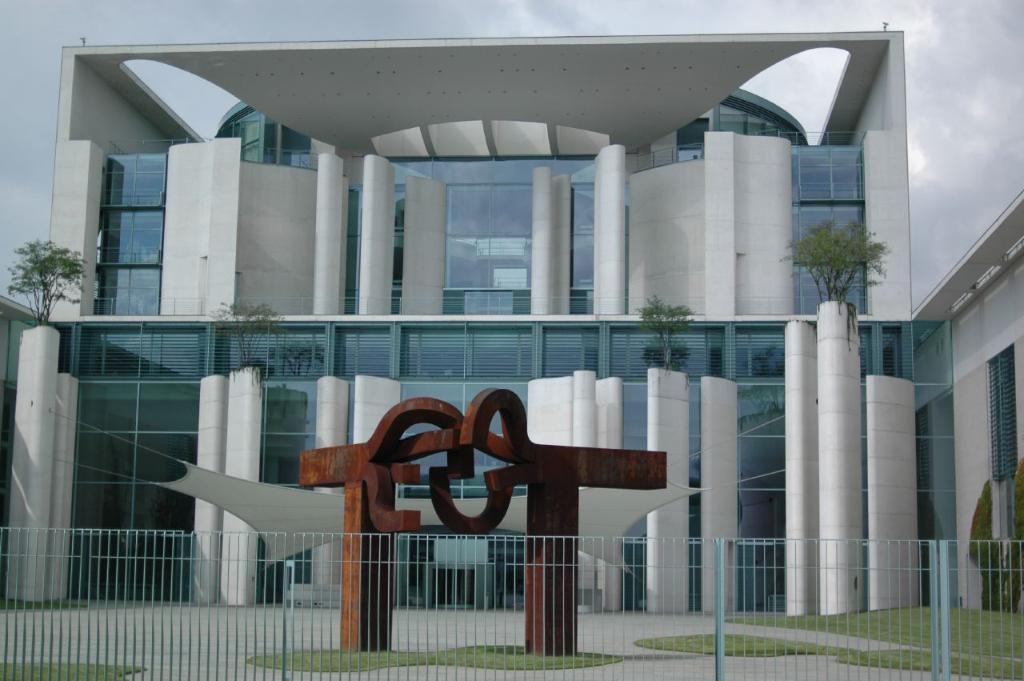What is the main structure in the center of the image? There is a building in the center of the image. What is located at the bottom of the image? There is fencing at the bottom of the image. What can be seen at the top of the image? The sky is visible at the top of the image. What is present in the sky? Clouds are present in the sky. How many friends can be seen playing with the kittens in the image? There are no friends or kittens present in the image. 